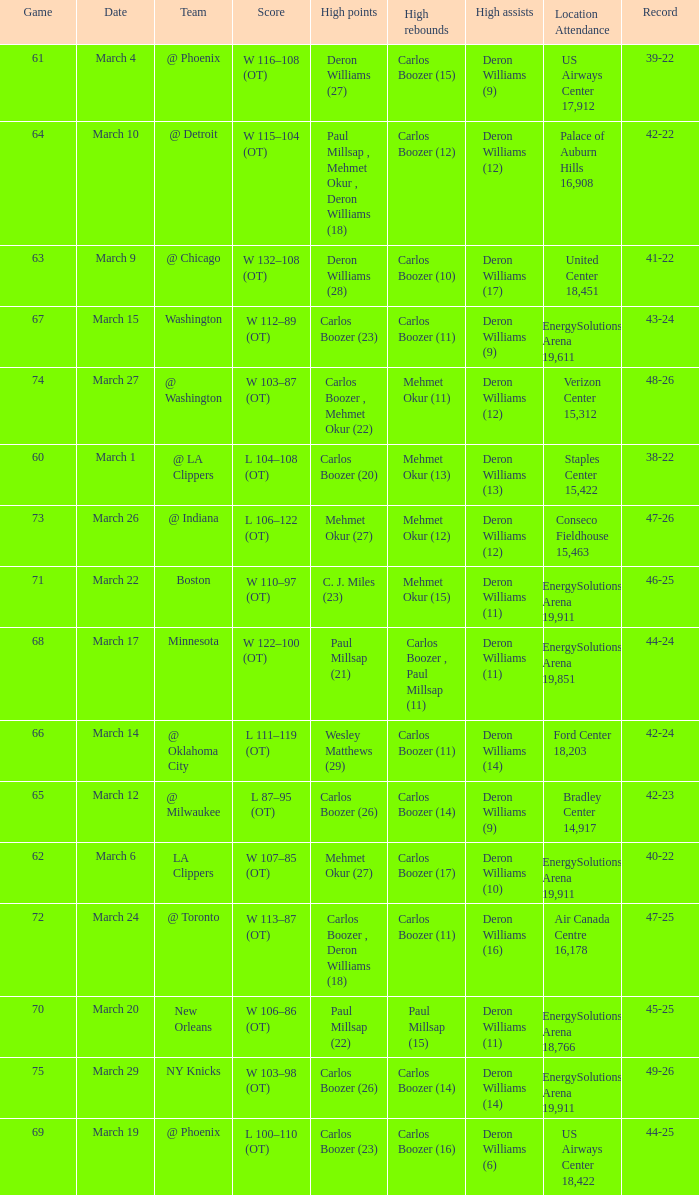Where was the March 24 game played? Air Canada Centre 16,178. 